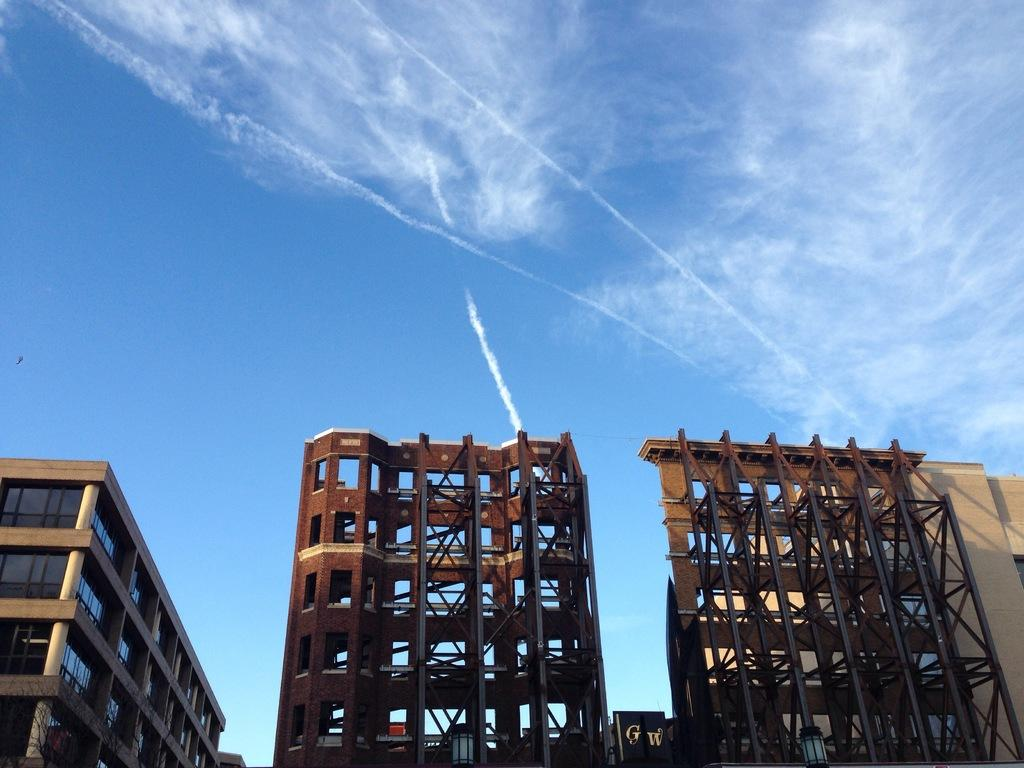What type of structures can be seen in the image? There are buildings in the image. What is visible at the top of the image? The sky is visible at the top of the image. How many boats are floating in the sky in the image? There are no boats visible in the image, and the sky is not filled with water for boats to float in. 